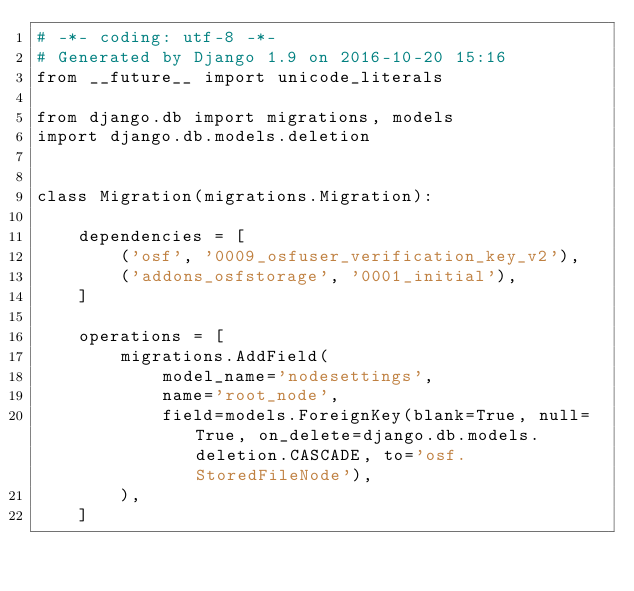Convert code to text. <code><loc_0><loc_0><loc_500><loc_500><_Python_># -*- coding: utf-8 -*-
# Generated by Django 1.9 on 2016-10-20 15:16
from __future__ import unicode_literals

from django.db import migrations, models
import django.db.models.deletion


class Migration(migrations.Migration):

    dependencies = [
        ('osf', '0009_osfuser_verification_key_v2'),
        ('addons_osfstorage', '0001_initial'),
    ]

    operations = [
        migrations.AddField(
            model_name='nodesettings',
            name='root_node',
            field=models.ForeignKey(blank=True, null=True, on_delete=django.db.models.deletion.CASCADE, to='osf.StoredFileNode'),
        ),
    ]
</code> 